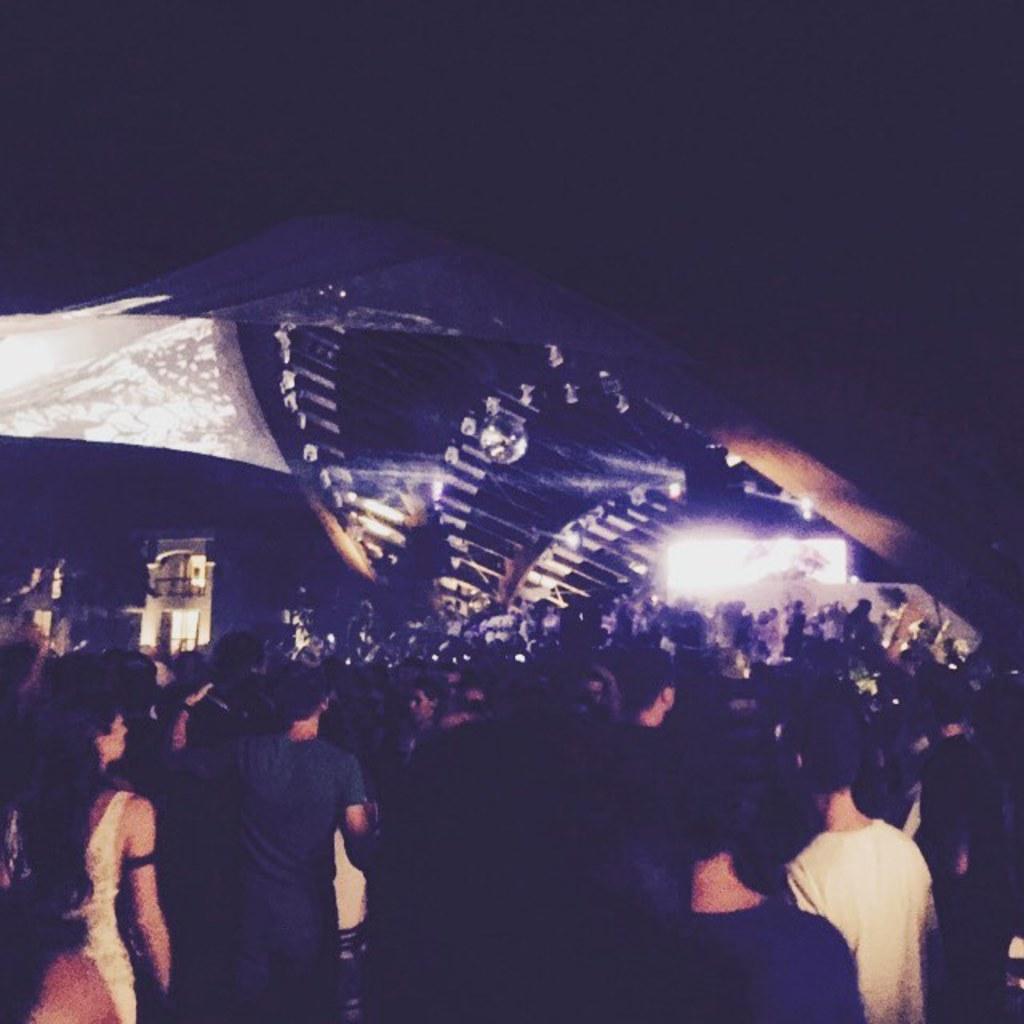How would you summarize this image in a sentence or two? In this image there are so many people standing on the ground, in front of them there is a big arch and buildings. 